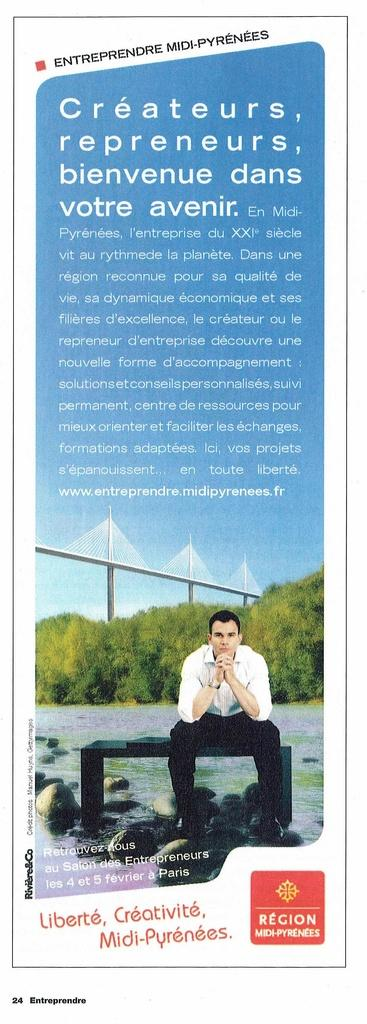What is present in the image that contains both images and text? There is a poster in the image that contains images and text. How many whips are being used to play volleyball in the image? There is no volleyball or whips present in the image; it only features a poster with images and text. 